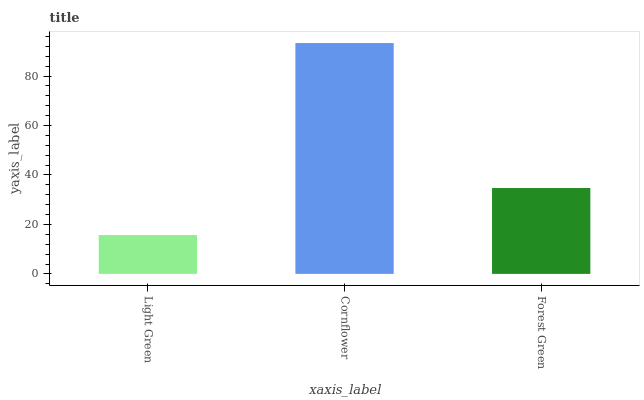Is Light Green the minimum?
Answer yes or no. Yes. Is Cornflower the maximum?
Answer yes or no. Yes. Is Forest Green the minimum?
Answer yes or no. No. Is Forest Green the maximum?
Answer yes or no. No. Is Cornflower greater than Forest Green?
Answer yes or no. Yes. Is Forest Green less than Cornflower?
Answer yes or no. Yes. Is Forest Green greater than Cornflower?
Answer yes or no. No. Is Cornflower less than Forest Green?
Answer yes or no. No. Is Forest Green the high median?
Answer yes or no. Yes. Is Forest Green the low median?
Answer yes or no. Yes. Is Cornflower the high median?
Answer yes or no. No. Is Cornflower the low median?
Answer yes or no. No. 